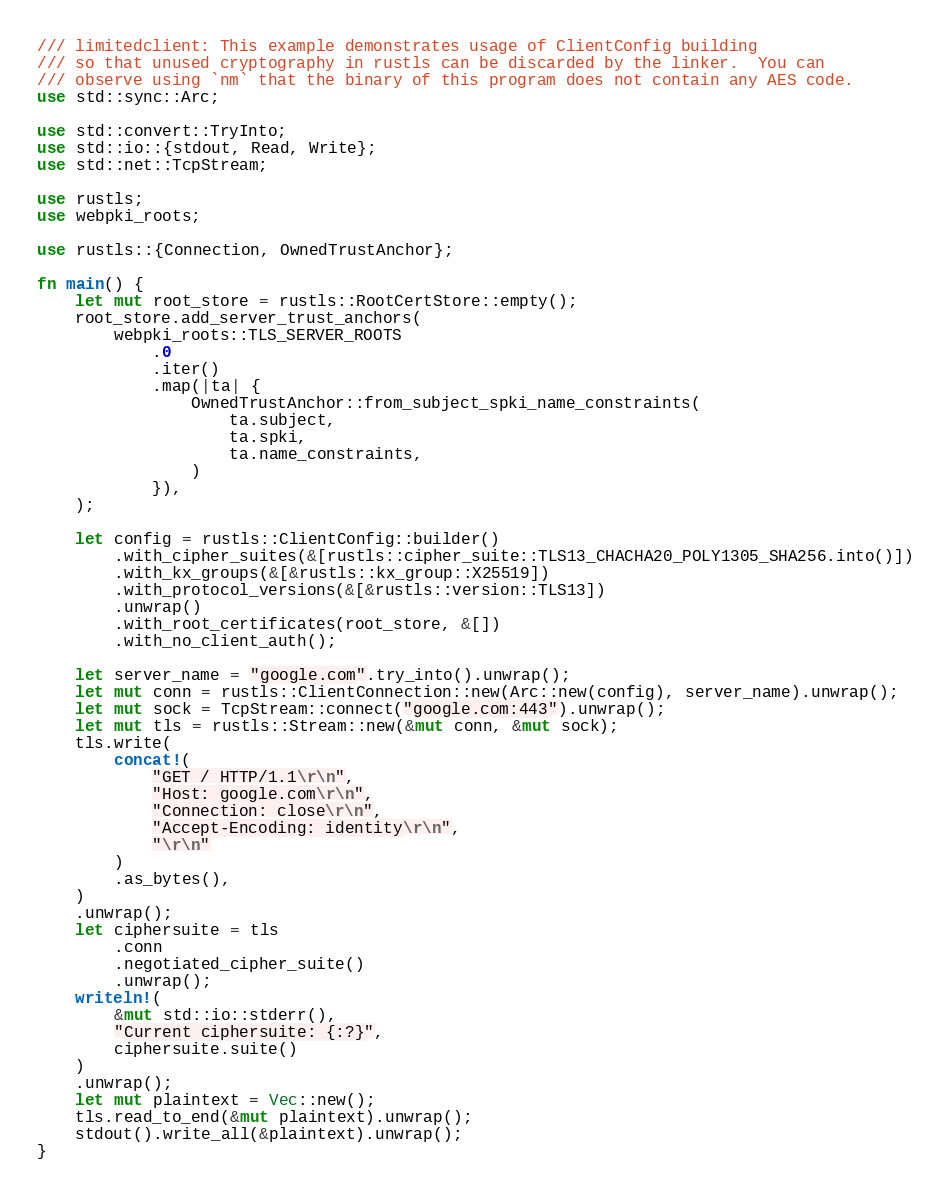Convert code to text. <code><loc_0><loc_0><loc_500><loc_500><_Rust_>/// limitedclient: This example demonstrates usage of ClientConfig building
/// so that unused cryptography in rustls can be discarded by the linker.  You can
/// observe using `nm` that the binary of this program does not contain any AES code.
use std::sync::Arc;

use std::convert::TryInto;
use std::io::{stdout, Read, Write};
use std::net::TcpStream;

use rustls;
use webpki_roots;

use rustls::{Connection, OwnedTrustAnchor};

fn main() {
    let mut root_store = rustls::RootCertStore::empty();
    root_store.add_server_trust_anchors(
        webpki_roots::TLS_SERVER_ROOTS
            .0
            .iter()
            .map(|ta| {
                OwnedTrustAnchor::from_subject_spki_name_constraints(
                    ta.subject,
                    ta.spki,
                    ta.name_constraints,
                )
            }),
    );

    let config = rustls::ClientConfig::builder()
        .with_cipher_suites(&[rustls::cipher_suite::TLS13_CHACHA20_POLY1305_SHA256.into()])
        .with_kx_groups(&[&rustls::kx_group::X25519])
        .with_protocol_versions(&[&rustls::version::TLS13])
        .unwrap()
        .with_root_certificates(root_store, &[])
        .with_no_client_auth();

    let server_name = "google.com".try_into().unwrap();
    let mut conn = rustls::ClientConnection::new(Arc::new(config), server_name).unwrap();
    let mut sock = TcpStream::connect("google.com:443").unwrap();
    let mut tls = rustls::Stream::new(&mut conn, &mut sock);
    tls.write(
        concat!(
            "GET / HTTP/1.1\r\n",
            "Host: google.com\r\n",
            "Connection: close\r\n",
            "Accept-Encoding: identity\r\n",
            "\r\n"
        )
        .as_bytes(),
    )
    .unwrap();
    let ciphersuite = tls
        .conn
        .negotiated_cipher_suite()
        .unwrap();
    writeln!(
        &mut std::io::stderr(),
        "Current ciphersuite: {:?}",
        ciphersuite.suite()
    )
    .unwrap();
    let mut plaintext = Vec::new();
    tls.read_to_end(&mut plaintext).unwrap();
    stdout().write_all(&plaintext).unwrap();
}
</code> 